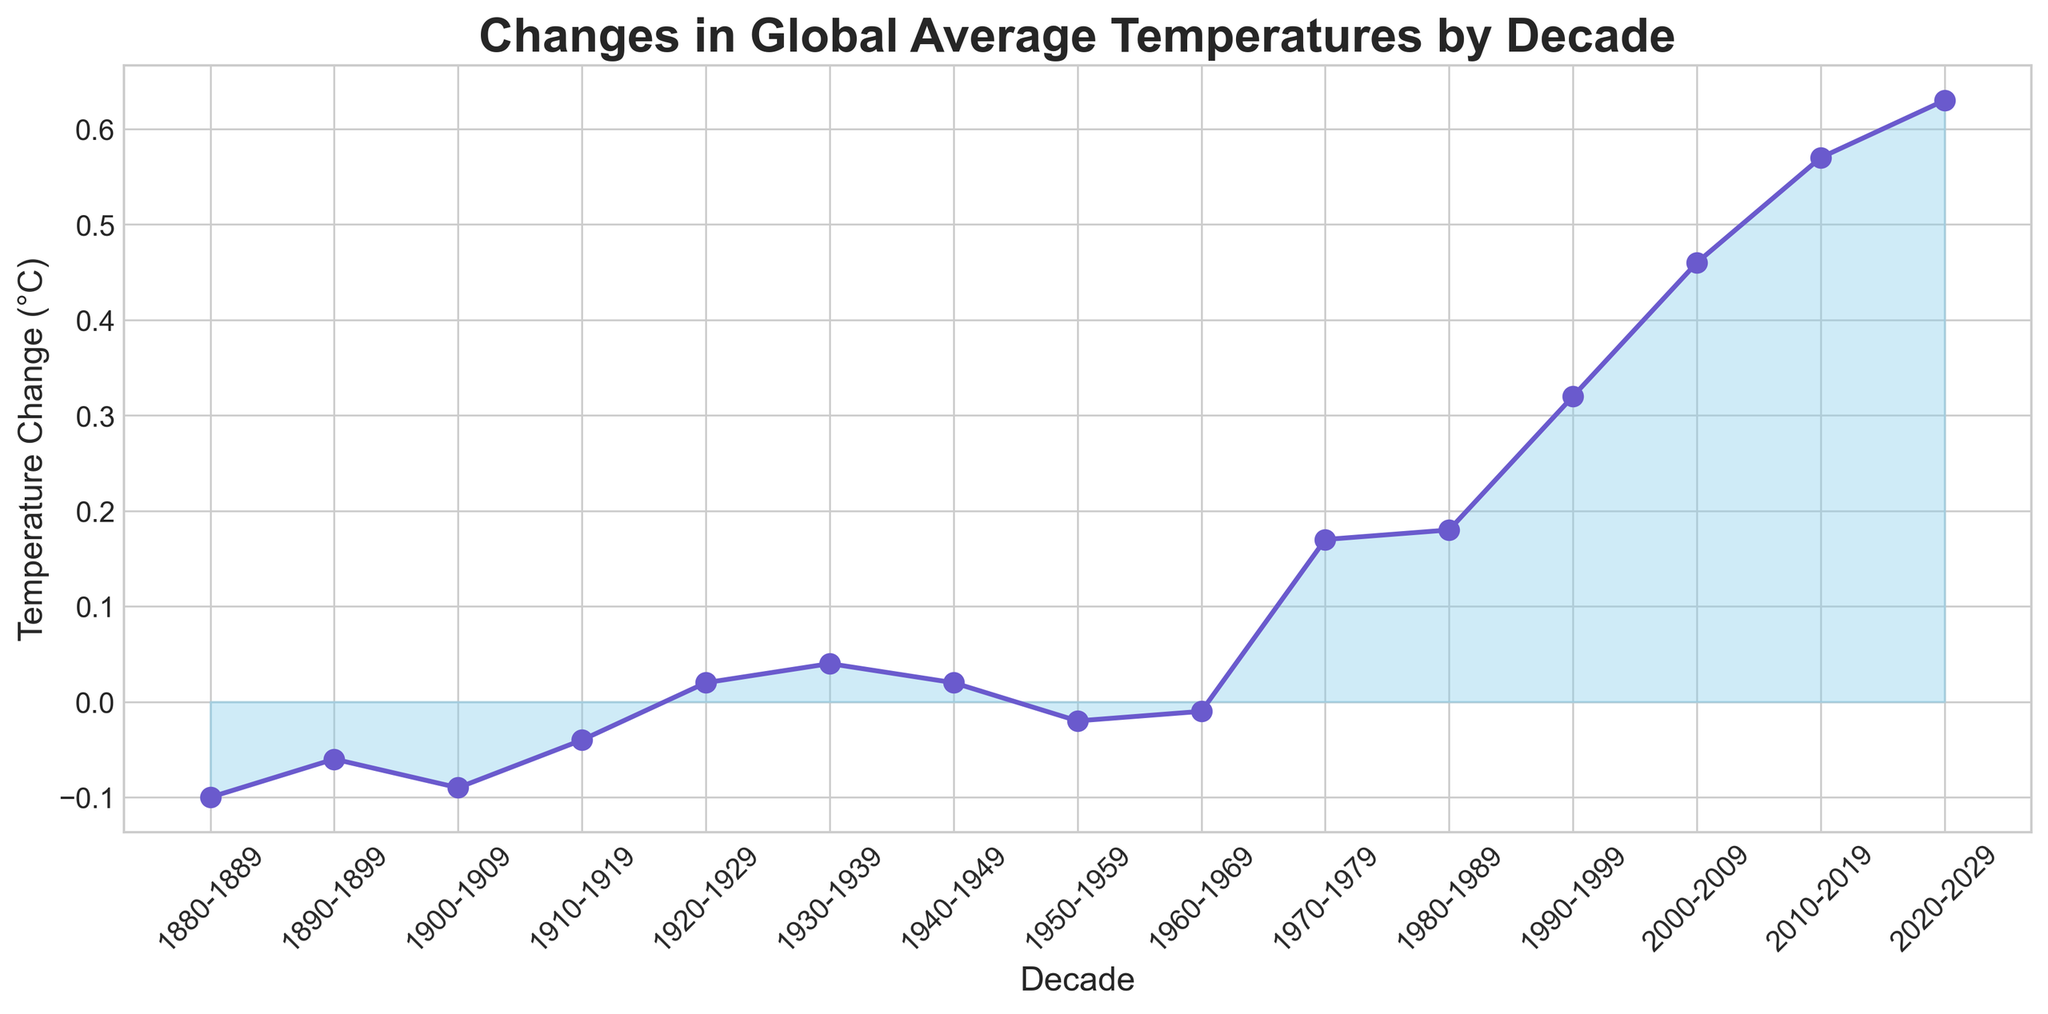Which decade had the highest global average temperature change? To find the decade with the highest global average temperature change, scan the plot for the peak value. The plot shows the highest temperature change around the decade of 2020-2029.
Answer: 2020-2029 How many decades had a negative temperature change? Count the number of points below the zero line in the area plot. There are four decades (1880-1889, 1890-1899, 1900-1909, 1950-1959) with negative temperature changes.
Answer: 4 What is the total temperature change from 1980 to 2020? Sum the temperature changes from the decades 1980-1989, 1990-1999, 2000-2009, and 2010-2019. The changes are 0.18, 0.32, 0.46, and 0.57 respectively, so 0.18 + 0.32 + 0.46 + 0.57 = 1.53°C.
Answer: 1.53°C Which decade saw the most significant increase in global average temperature compared to the previous decade? Look for the largest vertical jump between consecutive points. The biggest increase is from 1990-1999 to 2000-2009 (0.32 to 0.46), which is 0.14°C.
Answer: 1990-1999 to 2000-2009 How does the temperature change in the 1880s compare to the 2010s? Compare values for 1880-1889 (-0.10) and 2010-2019 (0.57). The change from -0.10 to 0.57 is an increase of 0.67°C.
Answer: 0.67°C increase What is the average temperature change across all decades? Sum all the temperature change values and divide by the number of decades (15). Total sum is -0.10 - 0.06 - 0.09 - 0.04 + 0.02 + 0.04 + 0.02 - 0.02 - 0.01 + 0.17 + 0.18 + 0.32 + 0.46 + 0.57 + 0.63 = 2.09. Average is 2.09 / 15 = 0.139°C.
Answer: 0.14°C During which decades did global temperatures increase after a period of decline? Identify periods where values switch from decreasing to increasing. After the decline in 1950-1959, the next decade begins an increase from 1960-1969 to 1970-1979.
Answer: 1960-1969 to 1970-1979 Which decade experienced the smallest temperature change on the positive side? Among the positive values, identify the smallest. The smallest positive change is in 1920-1929 and 1940-1949, both at 0.02°C.
Answer: 1920-1929 and 1940-1949 When did the global temperature change first exceed 0.1°C? Track the plot to find the first decade with a temperature change greater than 0.1°C. This first occurs in the 1970-1979 decade with a change of 0.17°C.
Answer: 1970-1979 